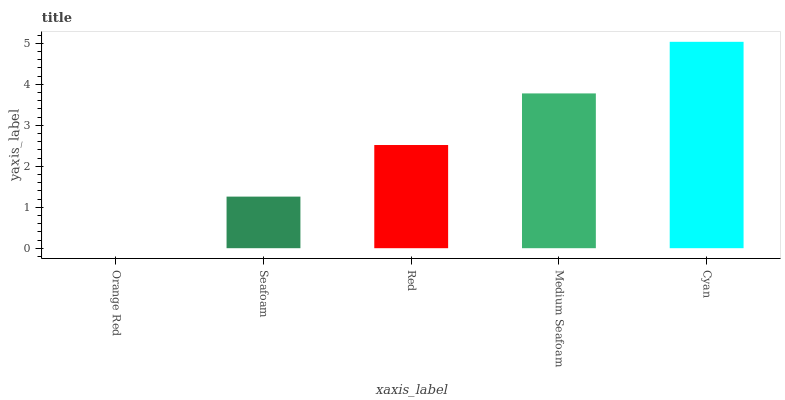Is Orange Red the minimum?
Answer yes or no. Yes. Is Cyan the maximum?
Answer yes or no. Yes. Is Seafoam the minimum?
Answer yes or no. No. Is Seafoam the maximum?
Answer yes or no. No. Is Seafoam greater than Orange Red?
Answer yes or no. Yes. Is Orange Red less than Seafoam?
Answer yes or no. Yes. Is Orange Red greater than Seafoam?
Answer yes or no. No. Is Seafoam less than Orange Red?
Answer yes or no. No. Is Red the high median?
Answer yes or no. Yes. Is Red the low median?
Answer yes or no. Yes. Is Seafoam the high median?
Answer yes or no. No. Is Seafoam the low median?
Answer yes or no. No. 